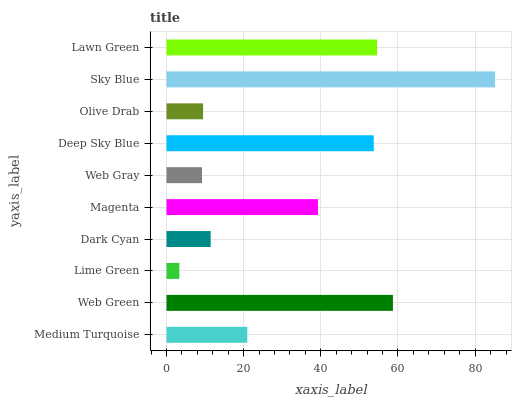Is Lime Green the minimum?
Answer yes or no. Yes. Is Sky Blue the maximum?
Answer yes or no. Yes. Is Web Green the minimum?
Answer yes or no. No. Is Web Green the maximum?
Answer yes or no. No. Is Web Green greater than Medium Turquoise?
Answer yes or no. Yes. Is Medium Turquoise less than Web Green?
Answer yes or no. Yes. Is Medium Turquoise greater than Web Green?
Answer yes or no. No. Is Web Green less than Medium Turquoise?
Answer yes or no. No. Is Magenta the high median?
Answer yes or no. Yes. Is Medium Turquoise the low median?
Answer yes or no. Yes. Is Deep Sky Blue the high median?
Answer yes or no. No. Is Olive Drab the low median?
Answer yes or no. No. 